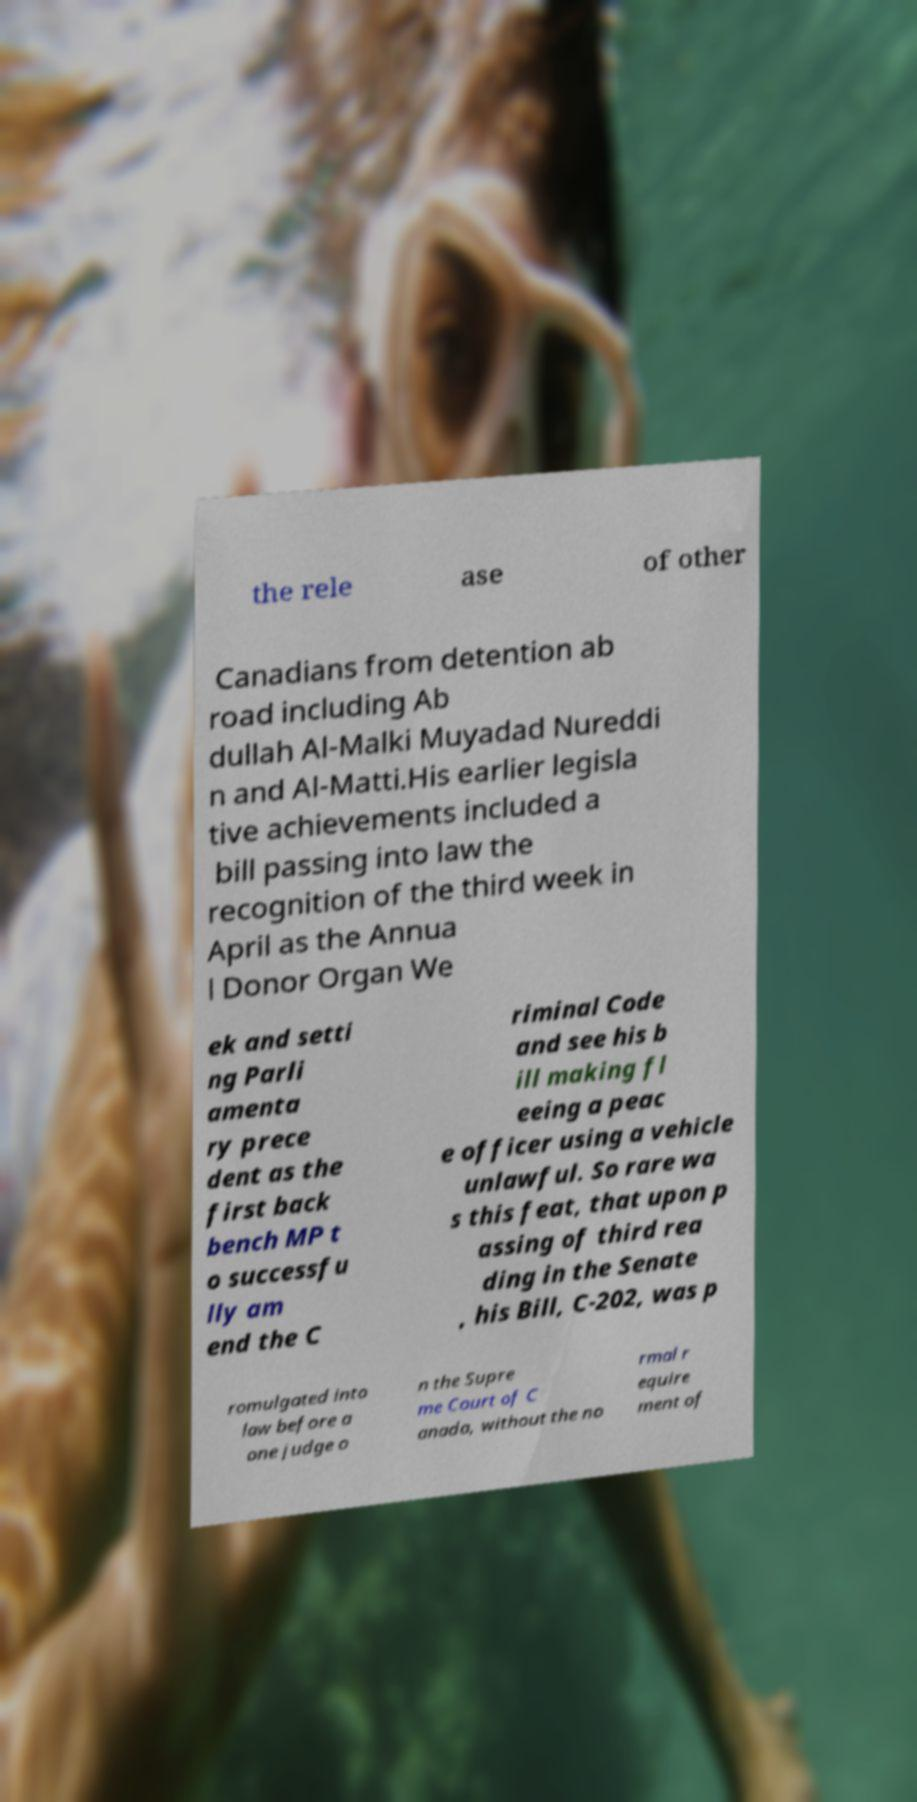Please identify and transcribe the text found in this image. the rele ase of other Canadians from detention ab road including Ab dullah Al-Malki Muyadad Nureddi n and Al-Matti.His earlier legisla tive achievements included a bill passing into law the recognition of the third week in April as the Annua l Donor Organ We ek and setti ng Parli amenta ry prece dent as the first back bench MP t o successfu lly am end the C riminal Code and see his b ill making fl eeing a peac e officer using a vehicle unlawful. So rare wa s this feat, that upon p assing of third rea ding in the Senate , his Bill, C-202, was p romulgated into law before a one judge o n the Supre me Court of C anada, without the no rmal r equire ment of 